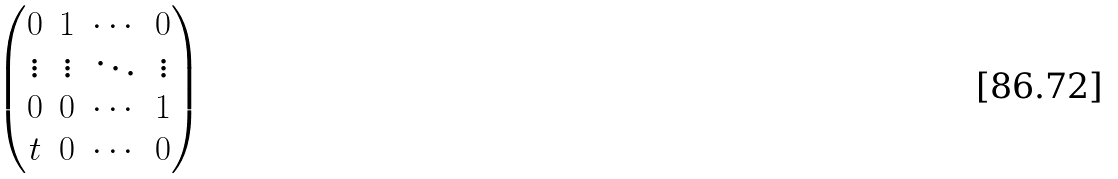Convert formula to latex. <formula><loc_0><loc_0><loc_500><loc_500>\begin{pmatrix} 0 & 1 & \cdots & 0 \\ \vdots & \vdots & \ddots & \vdots \\ 0 & 0 & \cdots & 1 \\ t & 0 & \cdots & 0 \\ \end{pmatrix}</formula> 